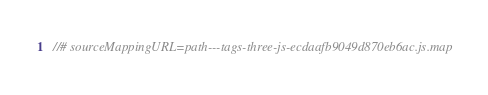<code> <loc_0><loc_0><loc_500><loc_500><_JavaScript_>//# sourceMappingURL=path---tags-three-js-ecdaafb9049d870eb6ac.js.map</code> 